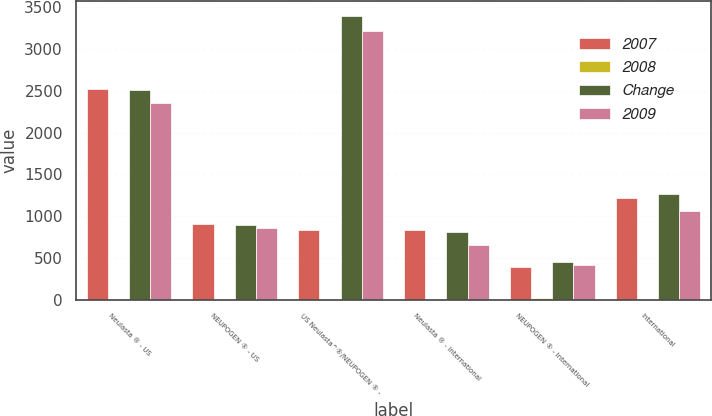Convert chart to OTSL. <chart><loc_0><loc_0><loc_500><loc_500><stacked_bar_chart><ecel><fcel>Neulasta ® - US<fcel>NEUPOGEN ® - US<fcel>US Neulasta^®/NEUPOGEN ® -<fcel>Neulasta ® - International<fcel>NEUPOGEN ® - International<fcel>International<nl><fcel>2007<fcel>2527<fcel>901<fcel>828<fcel>828<fcel>387<fcel>1215<nl><fcel>2008<fcel>1<fcel>1<fcel>1<fcel>2<fcel>13<fcel>3<nl><fcel>Change<fcel>2505<fcel>896<fcel>3401<fcel>813<fcel>445<fcel>1258<nl><fcel>2009<fcel>2351<fcel>861<fcel>3212<fcel>649<fcel>416<fcel>1065<nl></chart> 